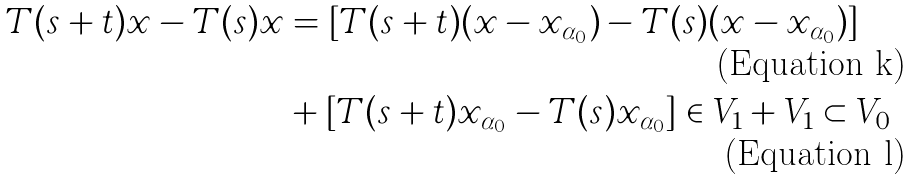<formula> <loc_0><loc_0><loc_500><loc_500>T ( s + t ) x - T ( s ) x & = [ T ( s + t ) ( x - x _ { \alpha _ { 0 } } ) - T ( s ) ( x - x _ { \alpha _ { 0 } } ) ] \\ & + [ T ( s + t ) x _ { \alpha _ { 0 } } - T ( s ) x _ { \alpha _ { 0 } } ] \in V _ { 1 } + V _ { 1 } \subset V _ { 0 }</formula> 